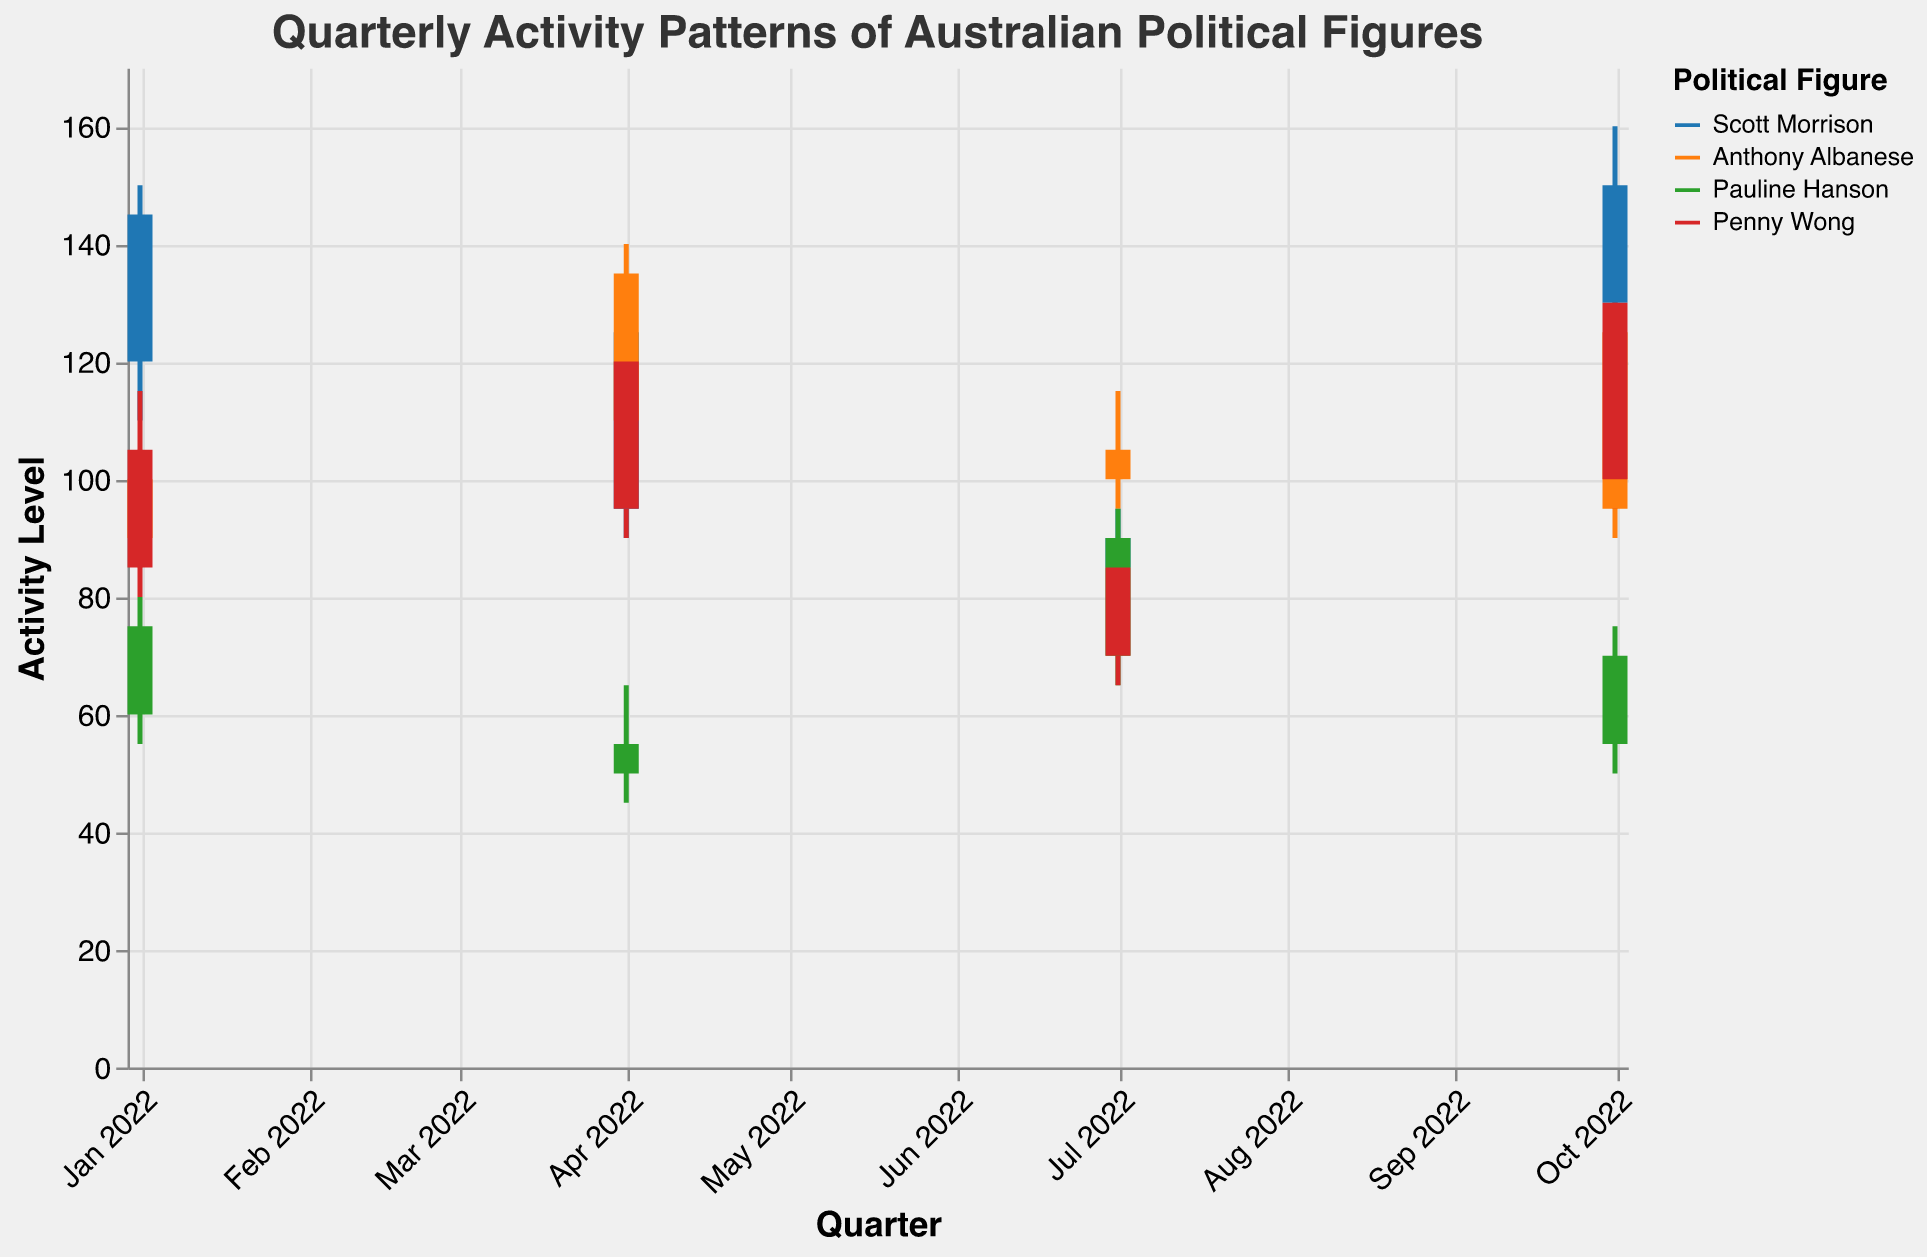Which political figure experienced the highest activity level in October 2022? The highest activity level is represented by the highest "High" value in October 2022. Scott Morrison has a "High" of 160, which is greater than the others.
Answer: Scott Morrison Which political figure had the lowest "Low" value in April 2022? The lowest "Low" value in April 2022 is found by comparing the "Low" values of all figures in that period. Pauline Hanson had a "Low" of 45.
Answer: Pauline Hanson Between which quarters did Pauline Hanson see the biggest increase in activity level? Compare the differences between "Close" values for consecutive quarters. From April to July 2022, her "Close" value increased from 55 to 90, the biggest change compared to other quarters.
Answer: April to July 2022 How did Anthony Albanese's activity level change from January 2022 to October 2022? Observing the "Close" values for Anthony Albanese from January (100) to October (125), there is an increase in his activity level.
Answer: Increased Which quarter had the lowest average activity level for all political figures combined? To find the quarter with the lowest average, compute the average "Close" values for each quarter. The 3rd quarter averages can be calculated as follows: (90+105+90+85)/4 = 92.5. This is the lowest compared to other quarters.
Answer: July 2022 